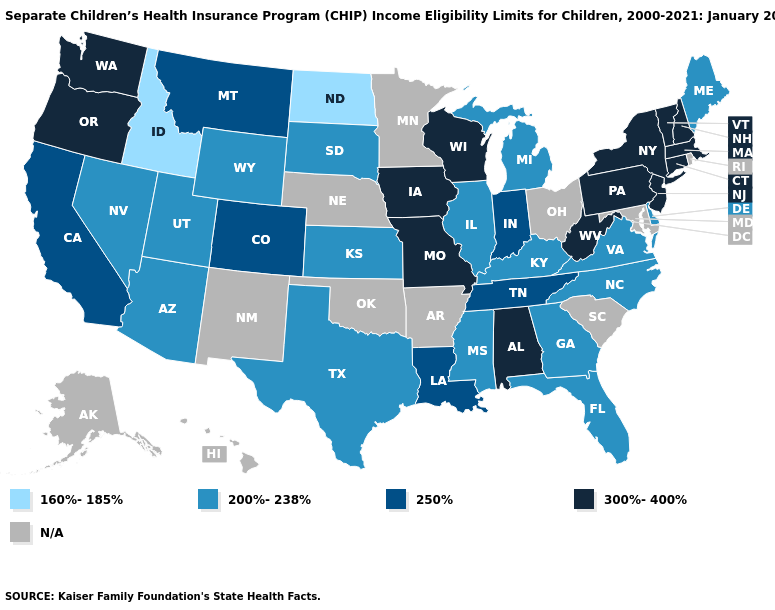What is the highest value in states that border Mississippi?
Give a very brief answer. 300%-400%. What is the value of Maine?
Answer briefly. 200%-238%. What is the value of Montana?
Quick response, please. 250%. Which states have the highest value in the USA?
Give a very brief answer. Alabama, Connecticut, Iowa, Massachusetts, Missouri, New Hampshire, New Jersey, New York, Oregon, Pennsylvania, Vermont, Washington, West Virginia, Wisconsin. Does Pennsylvania have the highest value in the USA?
Quick response, please. Yes. What is the lowest value in states that border California?
Short answer required. 200%-238%. Which states have the lowest value in the West?
Short answer required. Idaho. What is the value of Florida?
Write a very short answer. 200%-238%. What is the highest value in states that border Montana?
Concise answer only. 200%-238%. What is the highest value in states that border South Carolina?
Concise answer only. 200%-238%. What is the value of Iowa?
Answer briefly. 300%-400%. What is the value of Georgia?
Quick response, please. 200%-238%. What is the lowest value in states that border Louisiana?
Give a very brief answer. 200%-238%. 